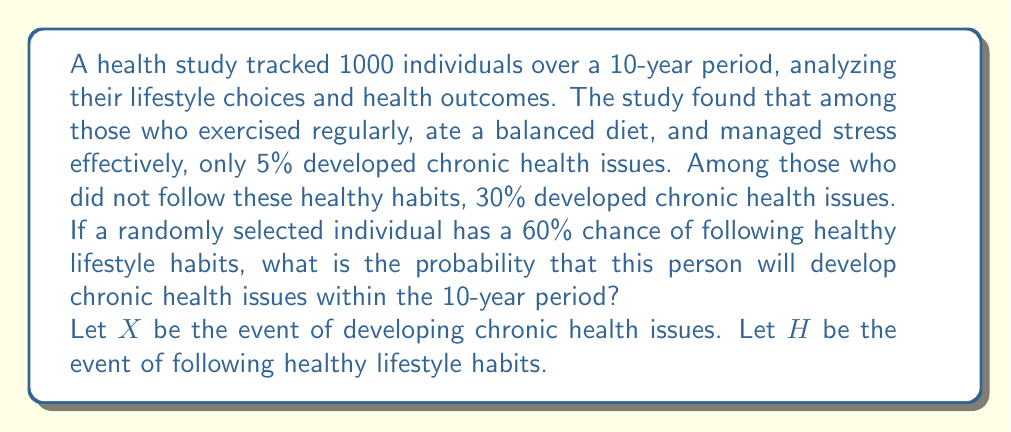Solve this math problem. Let's approach this step-by-step using the law of total probability:

1) We are given:
   $P(H) = 0.60$ (probability of following healthy habits)
   $P(X|H) = 0.05$ (probability of health issues given healthy habits)
   $P(X|\text{not }H) = 0.30$ (probability of health issues given unhealthy habits)

2) We need to find $P(X)$. The law of total probability states:
   $$P(X) = P(X|H) \cdot P(H) + P(X|\text{not }H) \cdot P(\text{not }H)$$

3) We know $P(H) = 0.60$, so $P(\text{not }H) = 1 - P(H) = 0.40$

4) Now we can substitute all values into the equation:
   $$P(X) = 0.05 \cdot 0.60 + 0.30 \cdot 0.40$$

5) Calculating:
   $$P(X) = 0.03 + 0.12 = 0.15$$

6) Therefore, the probability of developing chronic health issues is 0.15 or 15%.
Answer: 0.15 